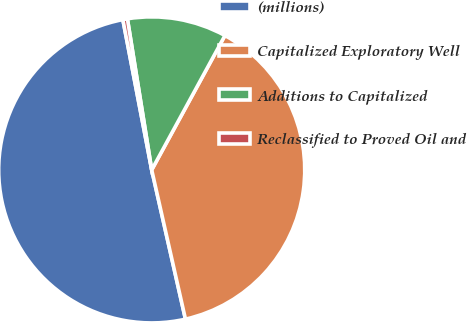Convert chart. <chart><loc_0><loc_0><loc_500><loc_500><pie_chart><fcel>(millions)<fcel>Capitalized Exploratory Well<fcel>Additions to Capitalized<fcel>Reclassified to Proved Oil and<nl><fcel>50.52%<fcel>38.52%<fcel>10.48%<fcel>0.48%<nl></chart> 